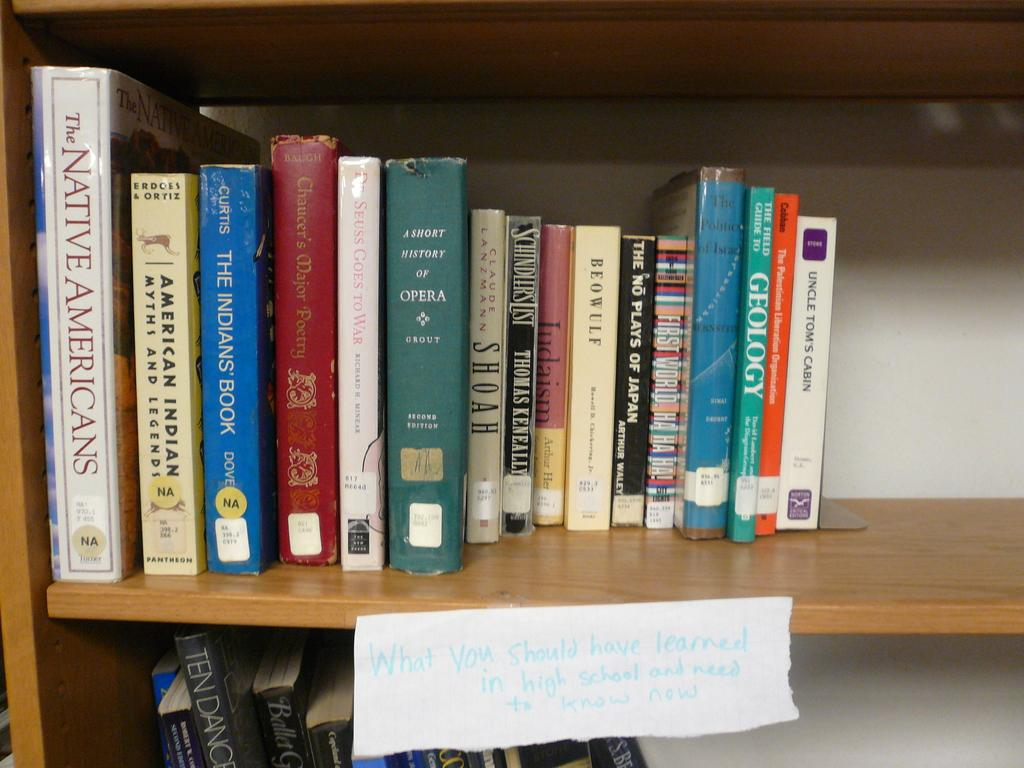<image>
Relay a brief, clear account of the picture shown. A field guide to Geology sits with other books on a wooden shelf. 